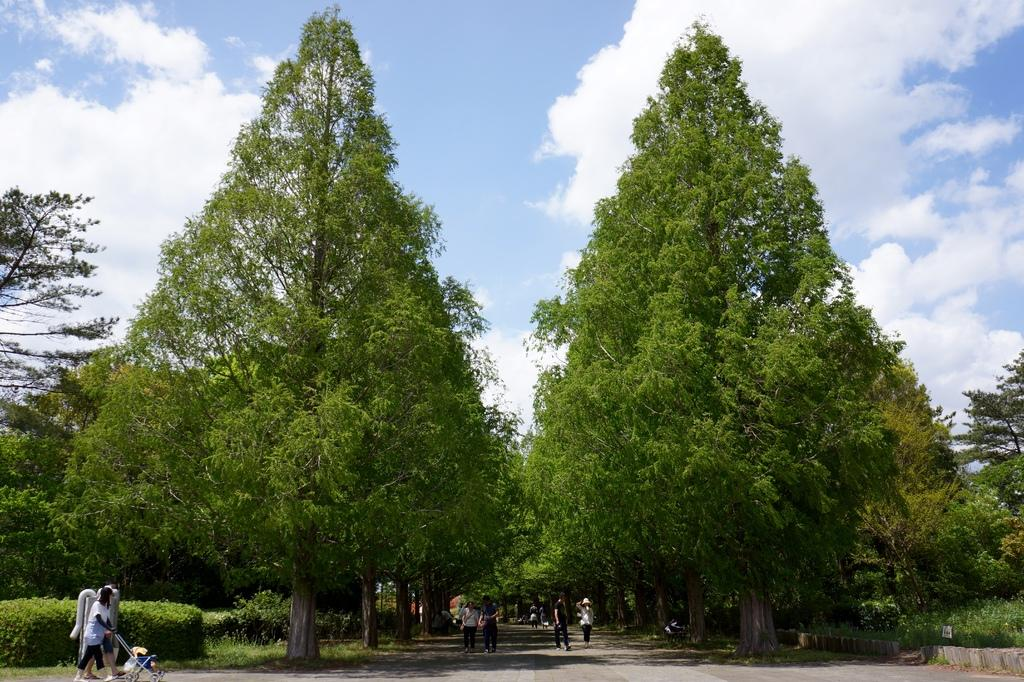What is located in the center of the image? There are trees in the center of the image. What is at the bottom of the image? There is a road at the bottom of the image. What are the people in the image doing? People are walking on the road. What is visible at the top of the image? The sky is visible at the top of the image. Where is the carpenter working in the image? There is no carpenter present in the image. What type of bears can be seen playing in the room in the image? There is no room or bears present in the image. 